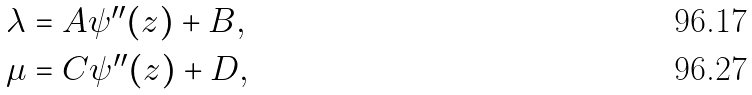Convert formula to latex. <formula><loc_0><loc_0><loc_500><loc_500>& \lambda = A \psi ^ { \prime \prime } ( z ) + B , \\ & \mu = C \psi ^ { \prime \prime } ( z ) + D ,</formula> 